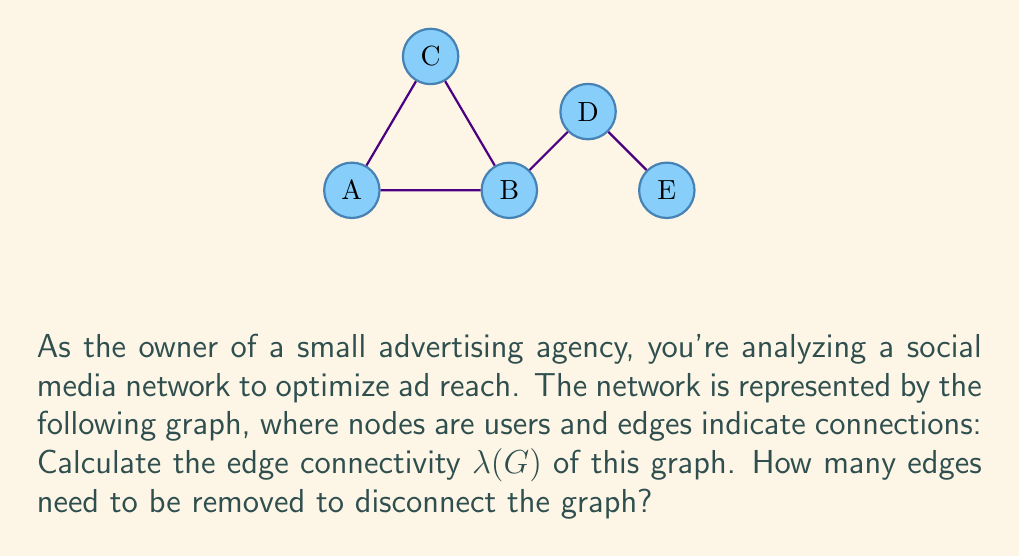Give your solution to this math problem. To find the edge connectivity $\lambda(G)$ of the graph, we need to determine the minimum number of edges that, when removed, will disconnect the graph. Let's approach this step-by-step:

1) First, let's recall the definition of edge connectivity:
   $\lambda(G)$ is the minimum number of edges whose removal results in a disconnected graph.

2) We need to examine all possible ways to disconnect the graph by removing edges:

   a) Removing edge B-D disconnects node E from the rest of the graph.
   b) Removing edges A-B and C-B disconnects node A from the rest.
   c) Removing edges B-C and C-A disconnects node C from the rest.
   d) Removing edges A-B, B-D, and B-C disconnects node B from the rest.

3) Among these options, the minimum number of edges to be removed is 1, which corresponds to removing edge B-D.

4) Therefore, the edge connectivity of this graph is:

   $$\lambda(G) = 1$$

This means that removing just one edge (B-D) is sufficient to disconnect the graph, making it the most vulnerable point for maintaining connectivity in this social media network.
Answer: $\lambda(G) = 1$ 